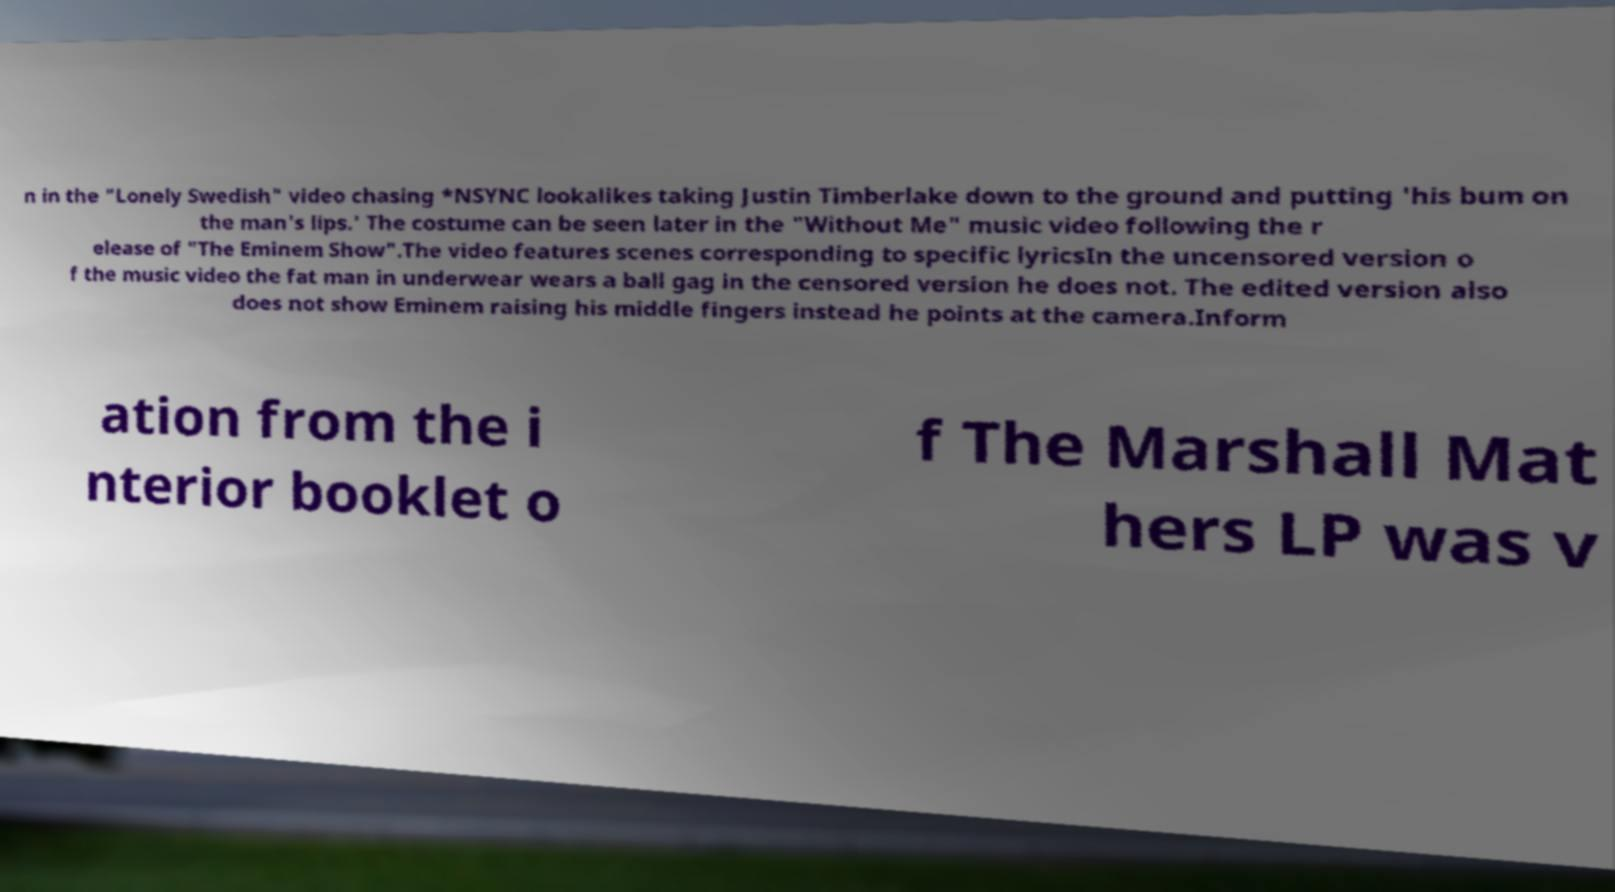Could you extract and type out the text from this image? n in the "Lonely Swedish" video chasing *NSYNC lookalikes taking Justin Timberlake down to the ground and putting 'his bum on the man's lips.' The costume can be seen later in the "Without Me" music video following the r elease of "The Eminem Show".The video features scenes corresponding to specific lyricsIn the uncensored version o f the music video the fat man in underwear wears a ball gag in the censored version he does not. The edited version also does not show Eminem raising his middle fingers instead he points at the camera.Inform ation from the i nterior booklet o f The Marshall Mat hers LP was v 